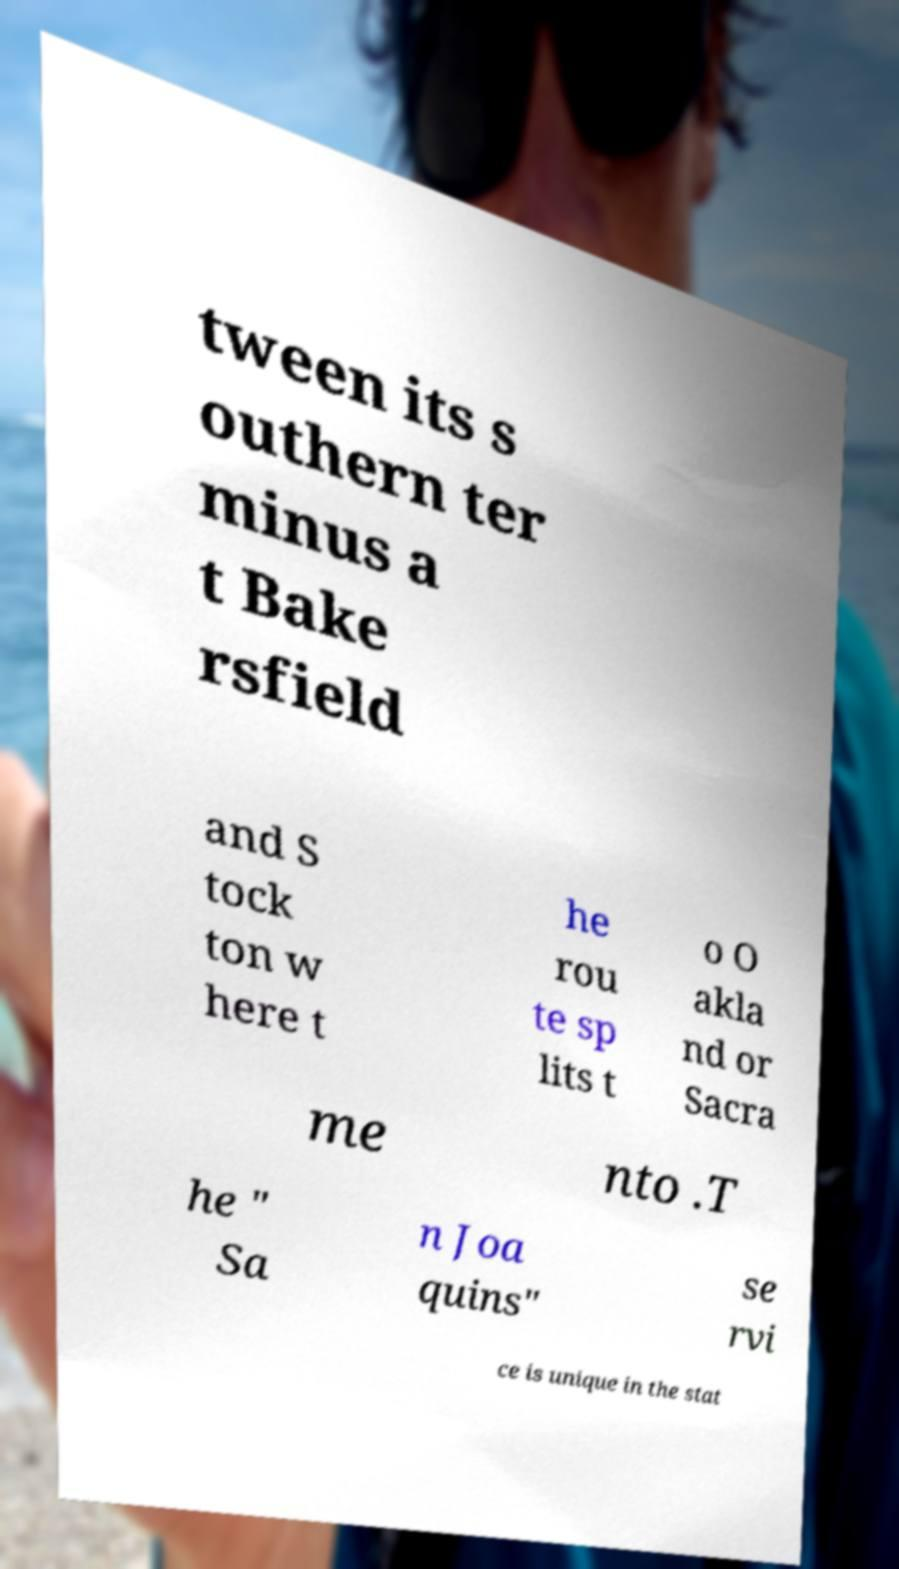For documentation purposes, I need the text within this image transcribed. Could you provide that? tween its s outhern ter minus a t Bake rsfield and S tock ton w here t he rou te sp lits t o O akla nd or Sacra me nto .T he " Sa n Joa quins" se rvi ce is unique in the stat 